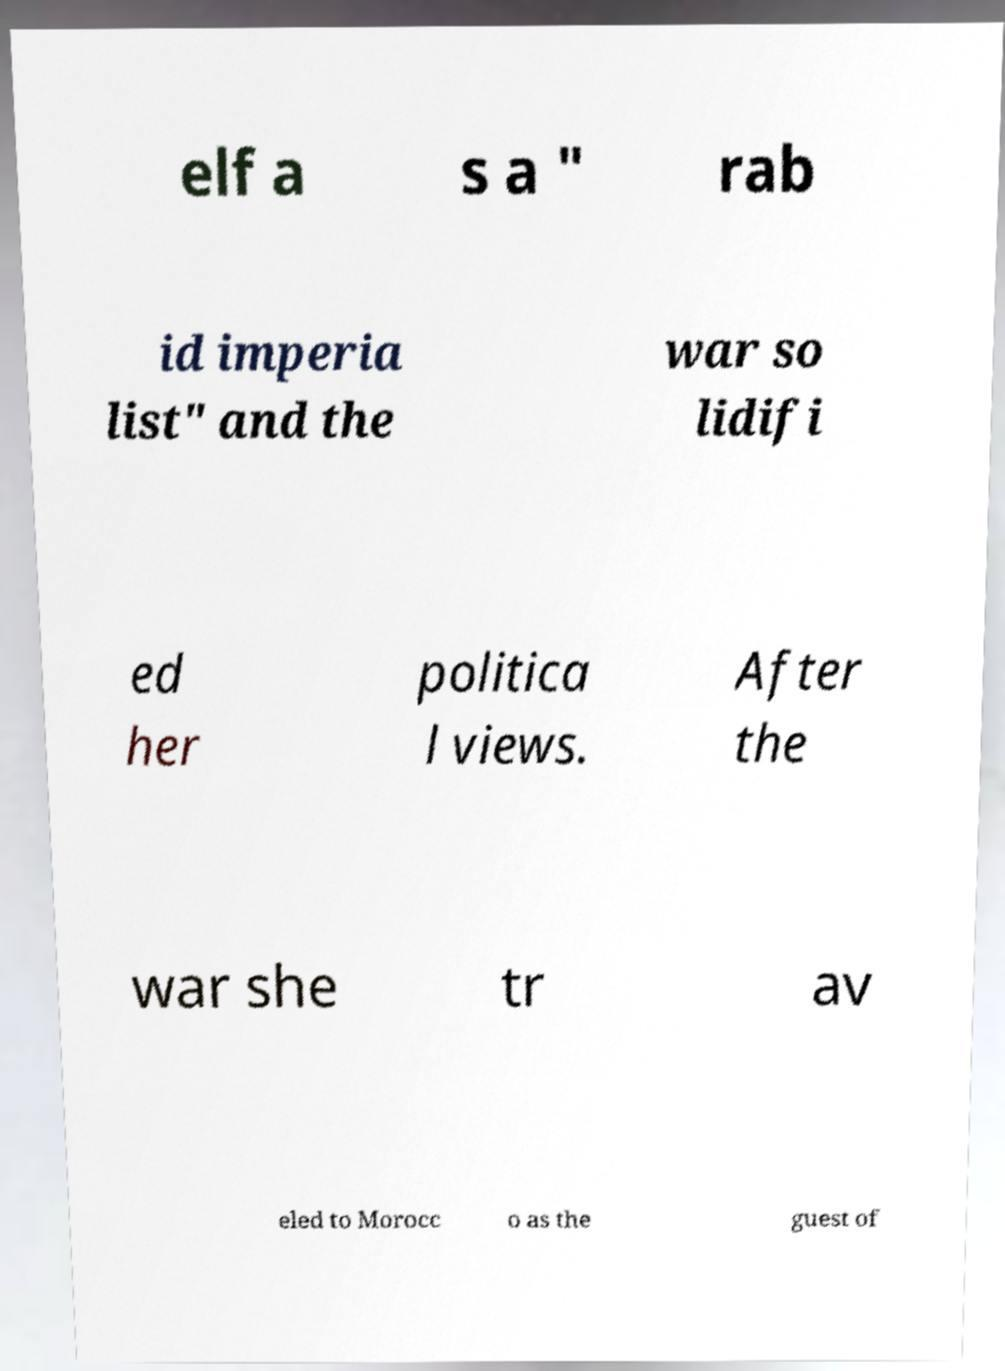Could you extract and type out the text from this image? elf a s a " rab id imperia list" and the war so lidifi ed her politica l views. After the war she tr av eled to Morocc o as the guest of 